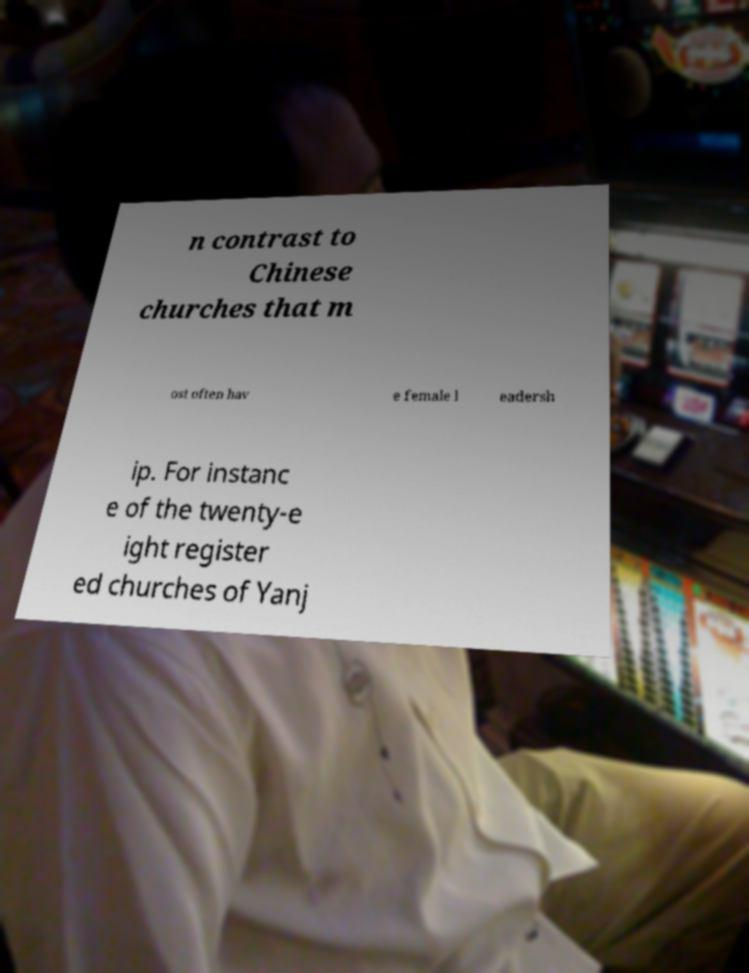For documentation purposes, I need the text within this image transcribed. Could you provide that? n contrast to Chinese churches that m ost often hav e female l eadersh ip. For instanc e of the twenty-e ight register ed churches of Yanj 